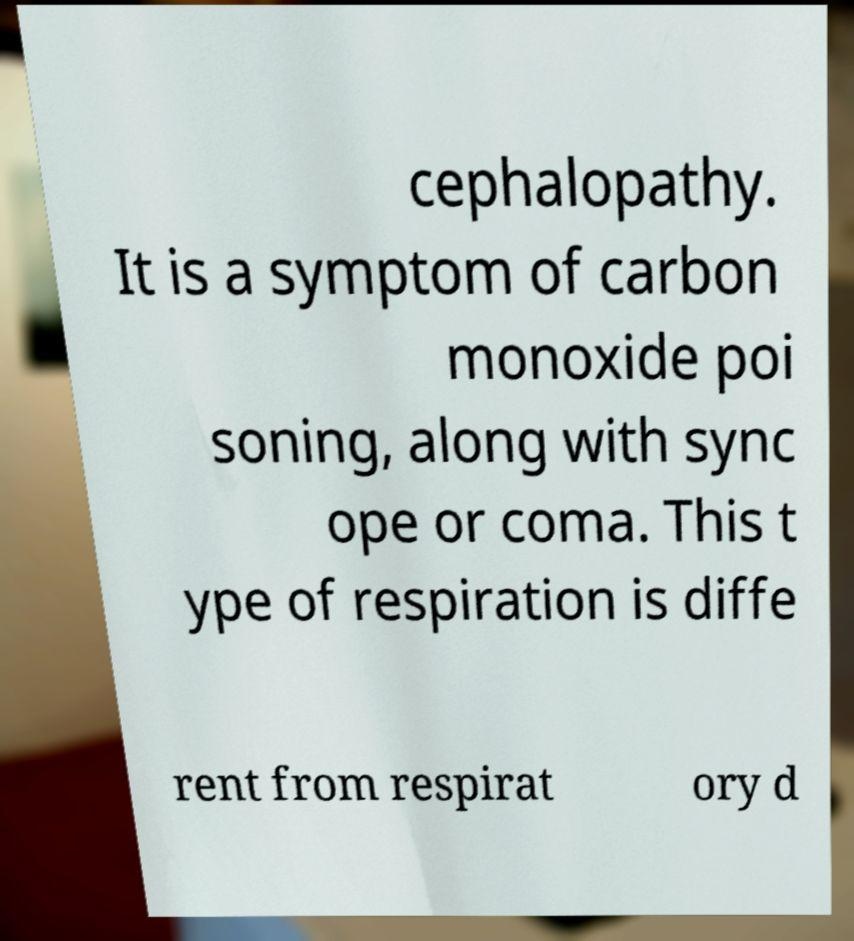Could you assist in decoding the text presented in this image and type it out clearly? cephalopathy. It is a symptom of carbon monoxide poi soning, along with sync ope or coma. This t ype of respiration is diffe rent from respirat ory d 